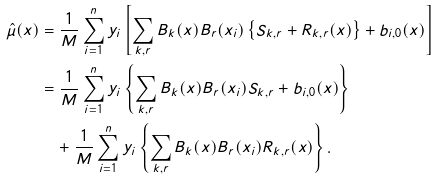Convert formula to latex. <formula><loc_0><loc_0><loc_500><loc_500>\hat { \mu } ( x ) & = \frac { 1 } { M } \sum _ { i = 1 } ^ { n } y _ { i } \left [ \sum _ { k , r } B _ { k } ( x ) B _ { r } ( x _ { i } ) \left \{ S _ { k , r } + R _ { k , r } ( x ) \right \} + b _ { i , 0 } ( x ) \right ] \\ & = \frac { 1 } { M } \sum _ { i = 1 } ^ { n } y _ { i } \left \{ \sum _ { k , r } B _ { k } ( x ) B _ { r } ( x _ { i } ) S _ { k , r } + b _ { i , 0 } ( x ) \right \} \\ & \quad + \frac { 1 } { M } \sum _ { i = 1 } ^ { n } y _ { i } \left \{ \sum _ { k , r } B _ { k } ( x ) B _ { r } ( x _ { i } ) R _ { k , r } ( x ) \right \} .</formula> 